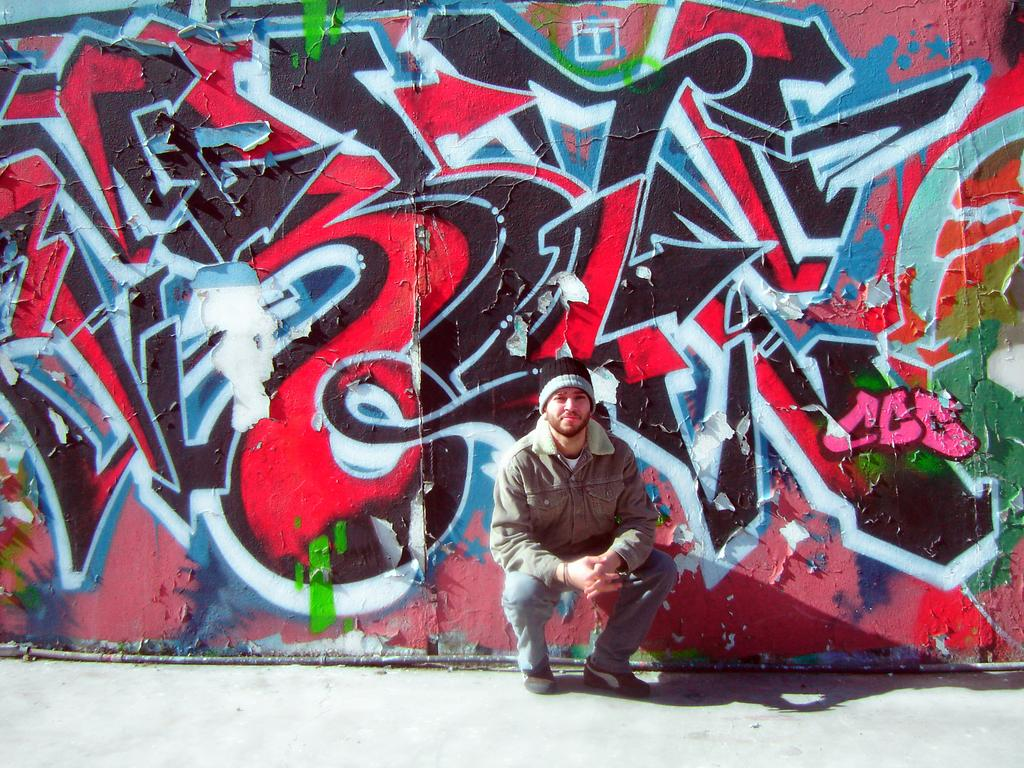What can be seen in the foreground of the image? There is a footpath in the foreground of the image. What is the main subject in the center of the image? There is a person in the center of the image. What can be seen in the background of the image? There is a wall with graffiti in the background of the image. Can you tell me how many roses are being held by the fireman in the image? There is no fireman or rose present in the image. What book is the person reading in the image? There is no book visible in the image. 